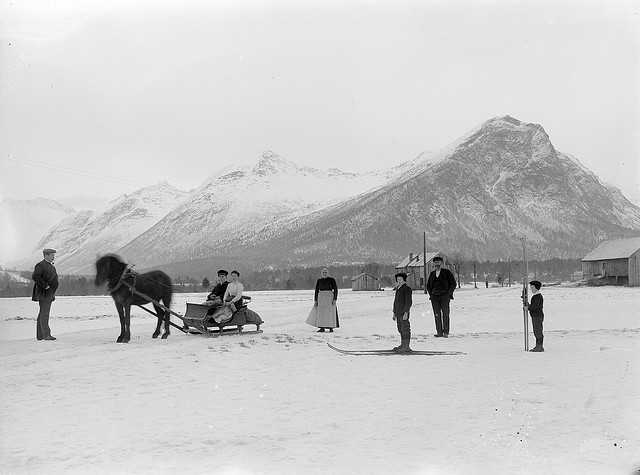<image>How deep is the snow? It is unknown how deep the snow is. It may not be very deep according to some descriptions. How deep is the snow? I am not sure how deep the snow is. It can be seen as not very deep or not deep. 